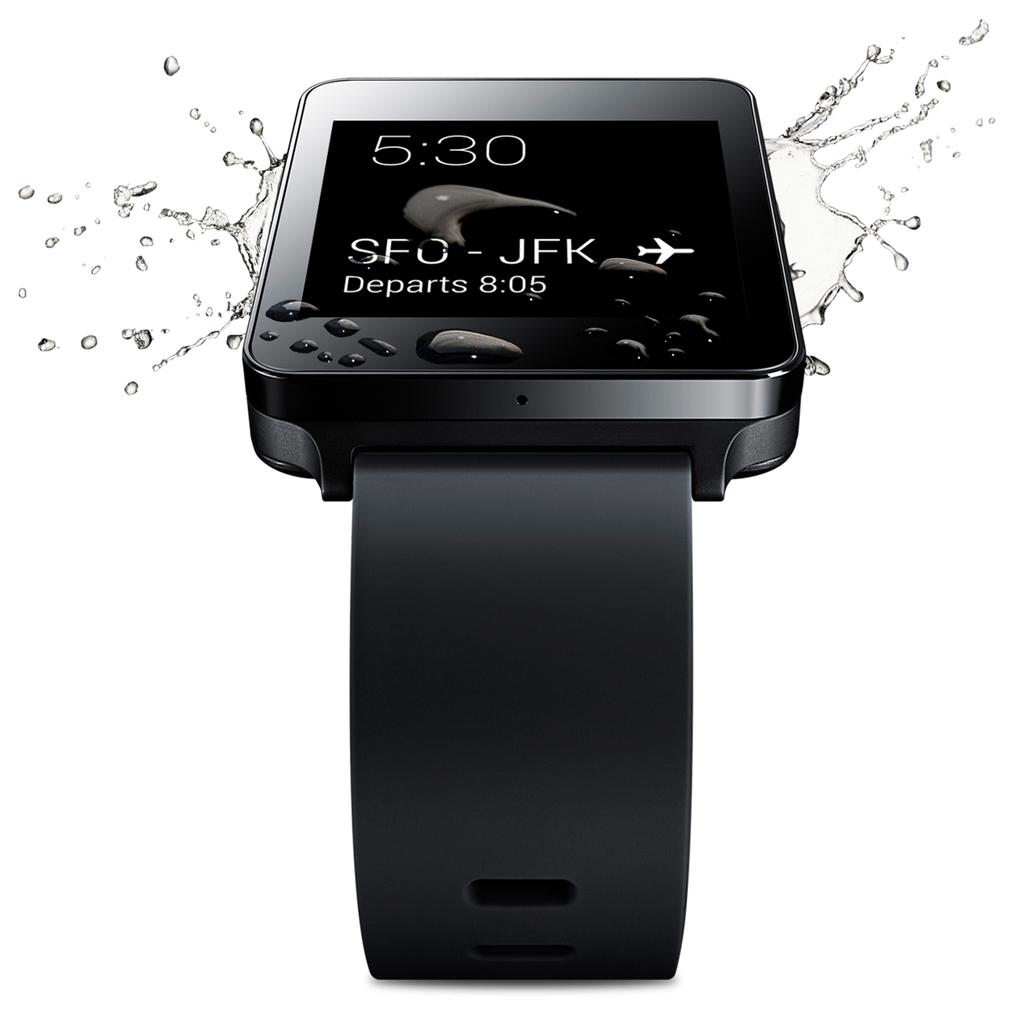What time is displayed?
Give a very brief answer. 5:30. What is the depart time?
Make the answer very short. 8:05. 